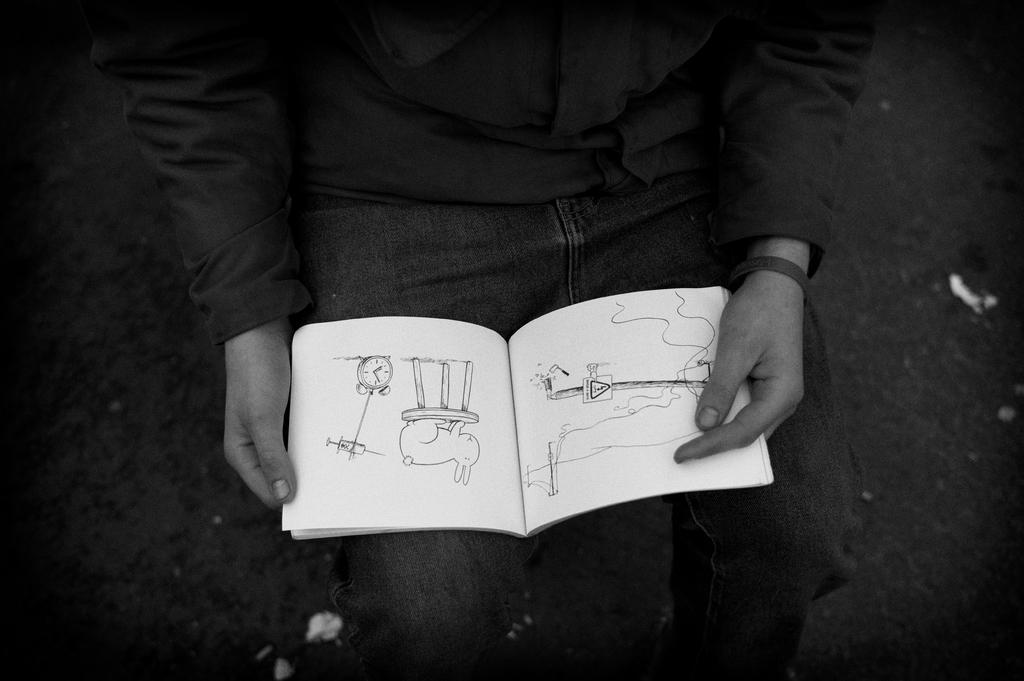Who is present in the image? There is a person in the image. What is the person holding? The person is holding a book. What can be found inside the book? There are drawings in the book. What is visible on the ground in the image? There are white objects on the ground. What type of experience can be gained from the cherry in the image? There is no cherry present in the image, so it is not possible to gain any experience from it. 